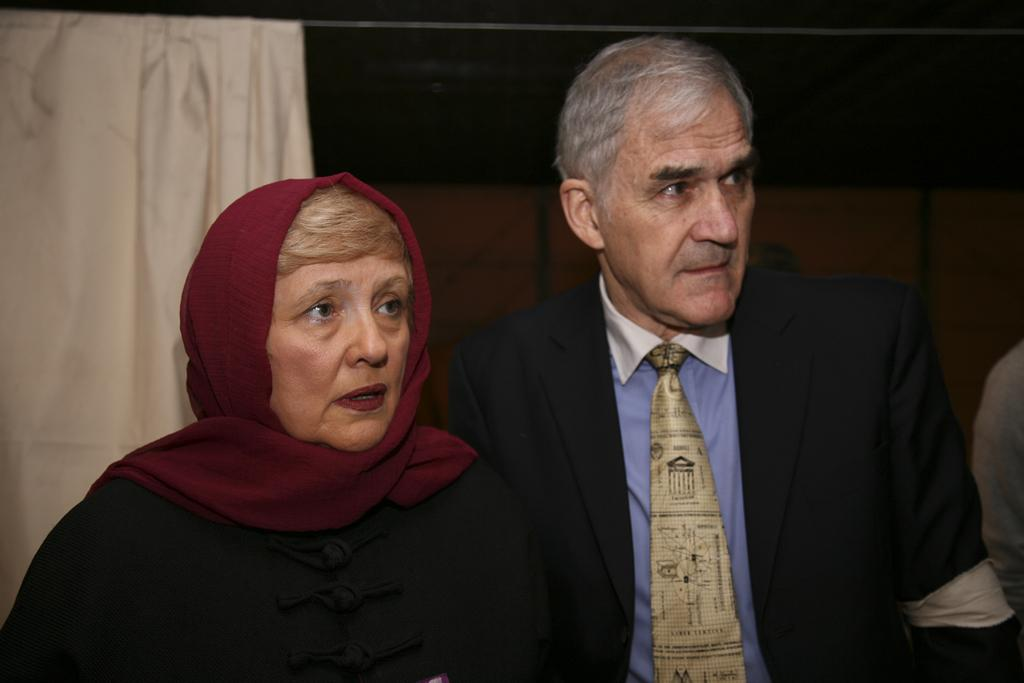How many people are present in the image? There are two people, a man and a woman, present in the image. What are the positions of the man and woman in the image? The man and woman are both standing in the image. What can be seen in the background of the image? There is a curtain in the background of the image. What is the woman wearing on her head? The woman is wearing a cloth on her head. What clothing items is the man wearing? The man is wearing a coat and a tie. How far can the man run in the image? There is no indication of the man running in the image, so it is not possible to determine how far he could run. 